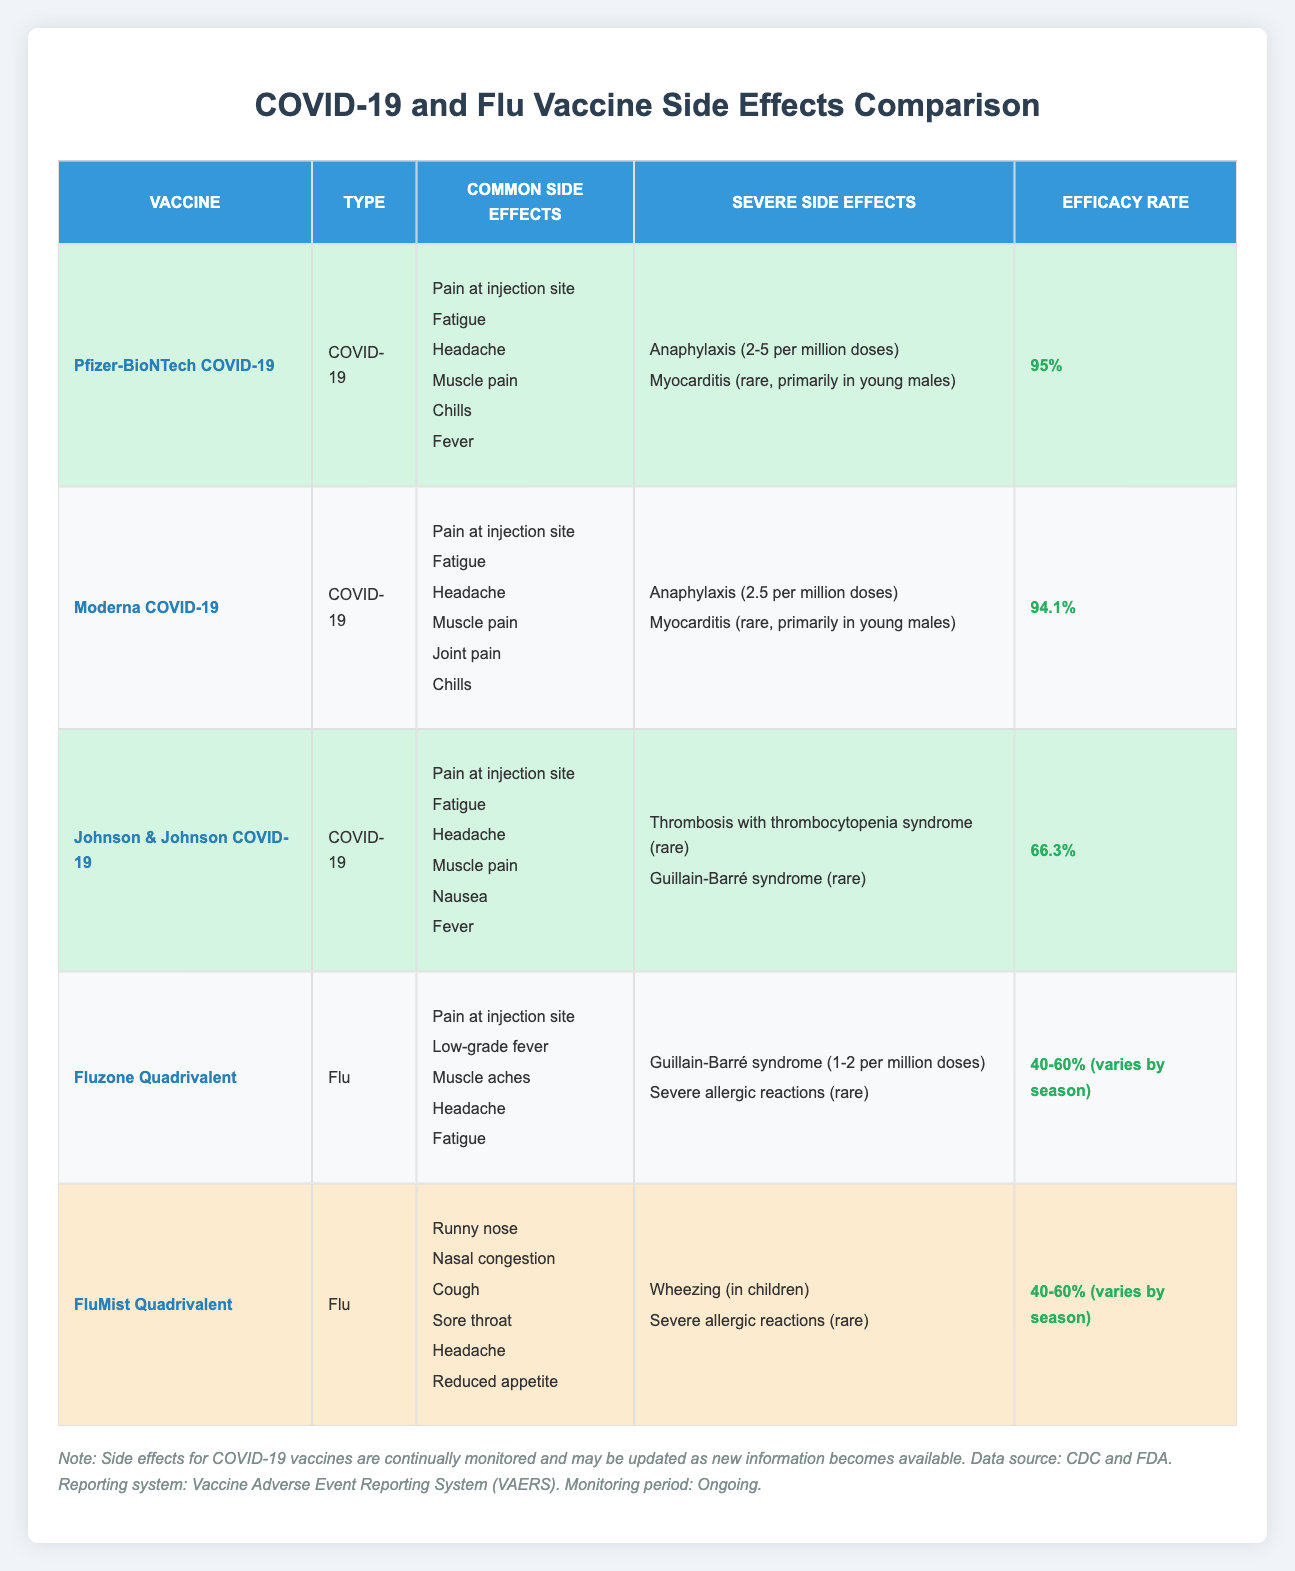What are the common side effects of the Pfizer-BioNTech COVID-19 vaccine? The common side effects for the Pfizer-BioNTech COVID-19 vaccine include pain at the injection site, fatigue, headache, muscle pain, chills, and fever. This information can be directly retrieved from the corresponding row in the table.
Answer: Pain at injection site, Fatigue, Headache, Muscle pain, Chills, Fever Which COVID-19 vaccine has the highest efficacy rate? To find the highest efficacy rate, we compare the efficacy rates of the COVID-19 vaccines listed in the table: Pfizer-BioNTech (95%), Moderna (94.1%), and Johnson & Johnson (66.3%). The highest is 95% for the Pfizer-BioNTech COVID-19 vaccine.
Answer: Pfizer-BioNTech COVID-19 (95%) Is Guillain-Barré syndrome a severe side effect of any flu vaccine? Yes, Guillain-Barré syndrome is listed as a severe side effect for both the Fluzone Quadrivalent and the Johnson & Johnson COVID-19 vaccines. This can be confirmed by checking the severe side effects under the respective vaccine categories in the table.
Answer: Yes What is the average efficacy rate of the flu vaccines listed? The efficacy rates for the flu vaccines are: Fluzone Quadrivalent (40-60%, averaging to 50%) and FluMist Quadrivalent (40-60%, also averaging to 50%). To find the average, we calculate (50 + 50) / 2 = 50. This gives us the average efficacy rate for the two flu vaccines.
Answer: 50% Among the vaccines listed, which has the least number of common side effects? We analyze the common side effects for each vaccine: Pfizer-BioNTech (6), Moderna (6), Johnson & Johnson (6), Fluzone Quadrivalent (5), and FluMist Quadrivalent (6). The Fluzone Quadrivalent vaccine has the least with 5 common side effects.
Answer: Fluzone Quadrivalent Does the Moderna COVID-19 vaccine have any severe side effects listed? Yes, the Moderna COVID-19 vaccine has two severe side effects listed: anaphylaxis (2.5 per million doses) and myocarditis (rare, primarily in young males). This is confirmed by the respective row information in the table.
Answer: Yes Which vaccine type generally has a lower efficacy rate, COVID-19 or flu? The flu vaccines have an efficacy rate that ranges from 40-60% (averaging to 50%), while the COVID-19 vaccines each have higher rates: Pfizer-BioNTech (95%), Moderna (94.1%), and Johnson & Johnson (66.3%). Thus, flu vaccines generally have a lower efficacy rate.
Answer: Flu What severe side effect is only reported for the Johnson & Johnson COVID-19 vaccine? The Johnson & Johnson COVID-19 vaccine uniquely lists "Thrombosis with thrombocytopenia syndrome (rare)" as a severe side effect, which is not reported for any of the other vaccines in the table.
Answer: Thrombosis with thrombocytopenia syndrome (rare) What common side effect do all COVID-19 vaccines share? By reviewing the common side effects of the COVID-19 vaccines listed, it is clear that "Pain at injection site," "Fatigue," and "Headache" are shared across all three COVID-19 vaccines: Pfizer-BioNTech, Moderna, and Johnson & Johnson.
Answer: Pain at injection site, Fatigue, Headache 